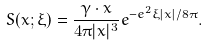Convert formula to latex. <formula><loc_0><loc_0><loc_500><loc_500>S ( x ; \xi ) = \frac { \gamma \cdot x } { 4 \pi | x | ^ { 3 } } e ^ { - e ^ { 2 } \xi | x | / 8 \pi } .</formula> 